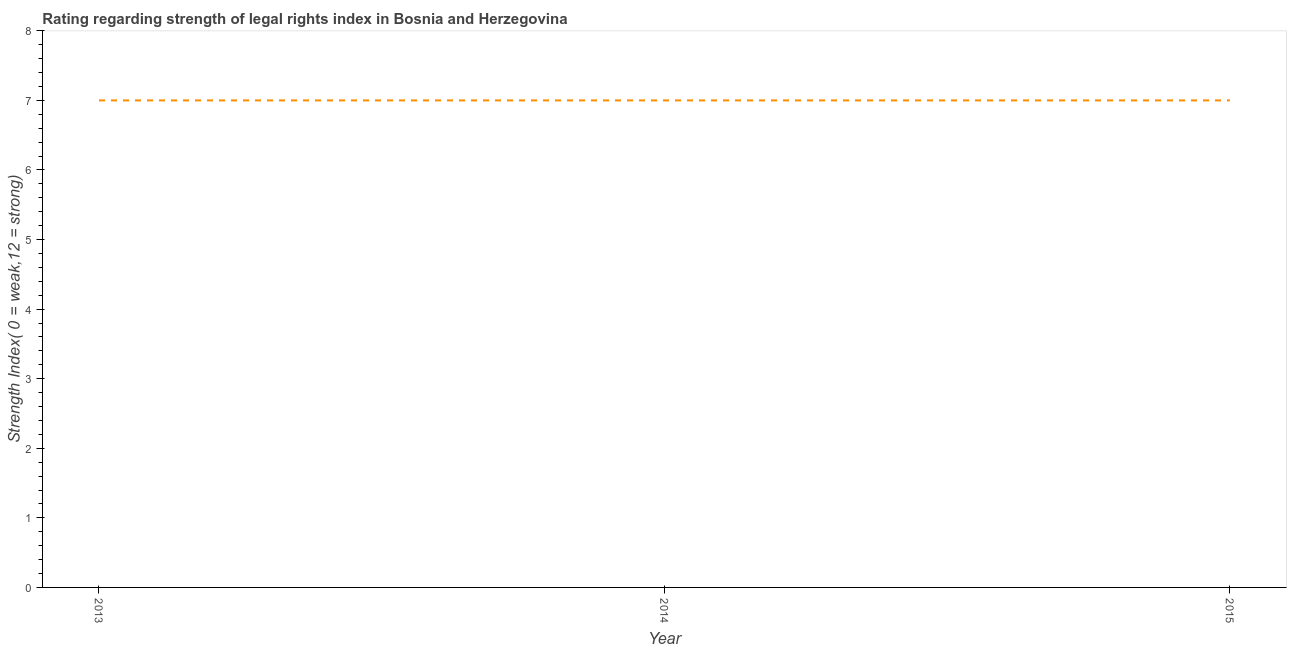What is the strength of legal rights index in 2013?
Make the answer very short. 7. Across all years, what is the maximum strength of legal rights index?
Your response must be concise. 7. Across all years, what is the minimum strength of legal rights index?
Ensure brevity in your answer.  7. In which year was the strength of legal rights index minimum?
Keep it short and to the point. 2013. What is the sum of the strength of legal rights index?
Your answer should be very brief. 21. In how many years, is the strength of legal rights index greater than 6 ?
Provide a succinct answer. 3. Is the strength of legal rights index in 2013 less than that in 2015?
Make the answer very short. No. What is the difference between the highest and the second highest strength of legal rights index?
Keep it short and to the point. 0. Is the sum of the strength of legal rights index in 2014 and 2015 greater than the maximum strength of legal rights index across all years?
Make the answer very short. Yes. What is the difference between the highest and the lowest strength of legal rights index?
Provide a succinct answer. 0. In how many years, is the strength of legal rights index greater than the average strength of legal rights index taken over all years?
Offer a very short reply. 0. Does the graph contain any zero values?
Provide a succinct answer. No. What is the title of the graph?
Give a very brief answer. Rating regarding strength of legal rights index in Bosnia and Herzegovina. What is the label or title of the X-axis?
Make the answer very short. Year. What is the label or title of the Y-axis?
Your answer should be compact. Strength Index( 0 = weak,12 = strong). What is the Strength Index( 0 = weak,12 = strong) of 2013?
Give a very brief answer. 7. What is the Strength Index( 0 = weak,12 = strong) of 2014?
Provide a succinct answer. 7. What is the difference between the Strength Index( 0 = weak,12 = strong) in 2013 and 2014?
Make the answer very short. 0. What is the difference between the Strength Index( 0 = weak,12 = strong) in 2013 and 2015?
Keep it short and to the point. 0. What is the ratio of the Strength Index( 0 = weak,12 = strong) in 2013 to that in 2014?
Keep it short and to the point. 1. What is the ratio of the Strength Index( 0 = weak,12 = strong) in 2013 to that in 2015?
Make the answer very short. 1. 